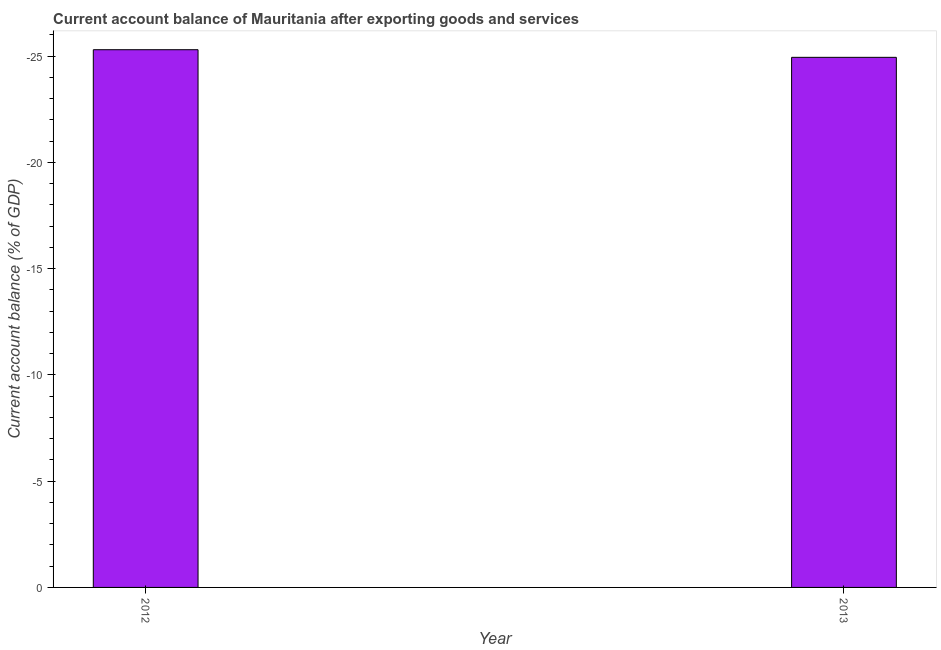What is the title of the graph?
Your response must be concise. Current account balance of Mauritania after exporting goods and services. What is the label or title of the X-axis?
Ensure brevity in your answer.  Year. What is the label or title of the Y-axis?
Your response must be concise. Current account balance (% of GDP). What is the current account balance in 2013?
Your response must be concise. 0. What is the average current account balance per year?
Offer a terse response. 0. How many bars are there?
Your response must be concise. 0. 